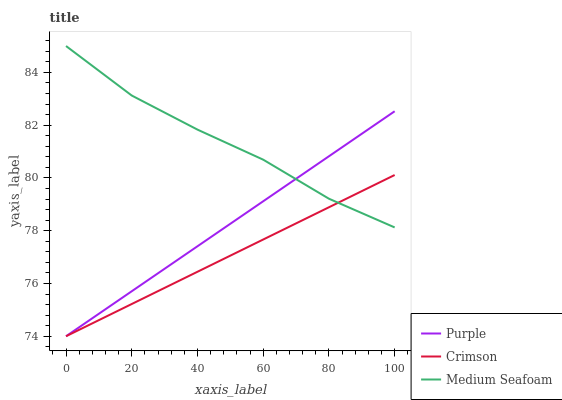Does Crimson have the minimum area under the curve?
Answer yes or no. Yes. Does Medium Seafoam have the maximum area under the curve?
Answer yes or no. Yes. Does Medium Seafoam have the minimum area under the curve?
Answer yes or no. No. Does Crimson have the maximum area under the curve?
Answer yes or no. No. Is Purple the smoothest?
Answer yes or no. Yes. Is Medium Seafoam the roughest?
Answer yes or no. Yes. Is Crimson the smoothest?
Answer yes or no. No. Is Crimson the roughest?
Answer yes or no. No. Does Purple have the lowest value?
Answer yes or no. Yes. Does Medium Seafoam have the lowest value?
Answer yes or no. No. Does Medium Seafoam have the highest value?
Answer yes or no. Yes. Does Crimson have the highest value?
Answer yes or no. No. Does Medium Seafoam intersect Crimson?
Answer yes or no. Yes. Is Medium Seafoam less than Crimson?
Answer yes or no. No. Is Medium Seafoam greater than Crimson?
Answer yes or no. No. 